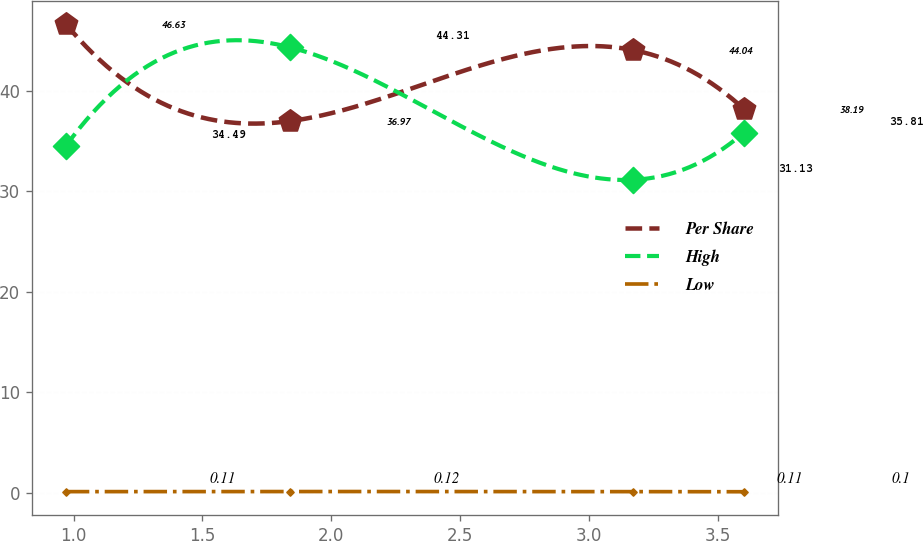Convert chart to OTSL. <chart><loc_0><loc_0><loc_500><loc_500><line_chart><ecel><fcel>Per Share<fcel>High<fcel>Low<nl><fcel>0.97<fcel>46.63<fcel>34.49<fcel>0.11<nl><fcel>1.84<fcel>36.97<fcel>44.31<fcel>0.12<nl><fcel>3.17<fcel>44.04<fcel>31.13<fcel>0.11<nl><fcel>3.6<fcel>38.19<fcel>35.81<fcel>0.1<nl></chart> 